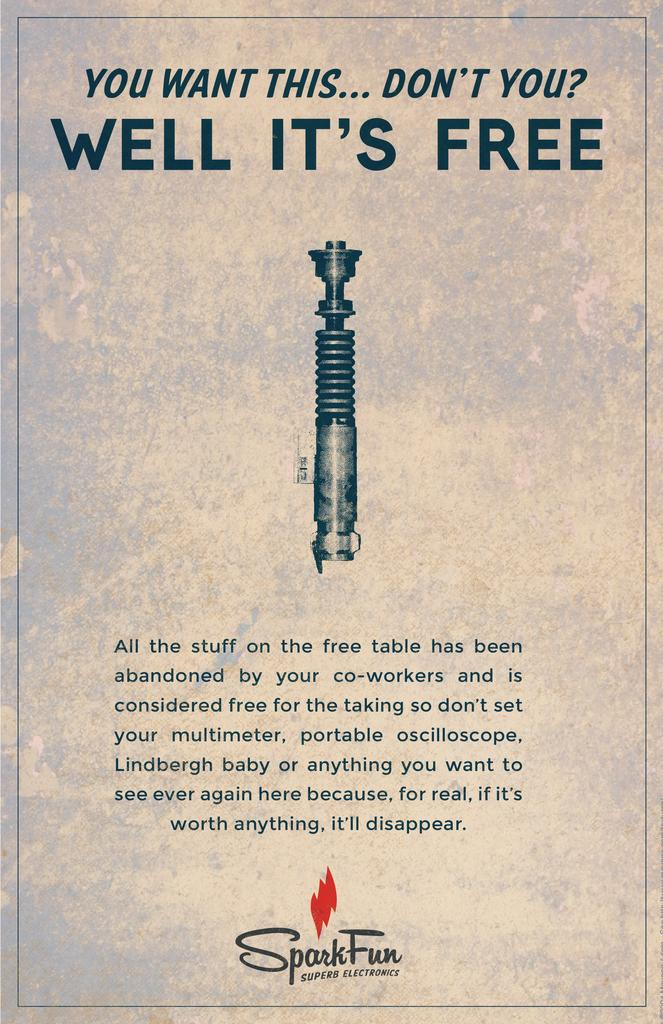<image>
Present a compact description of the photo's key features. a cover page featuring a lightsaber with the title reading " you want this don't you? well it's free" on the top. 